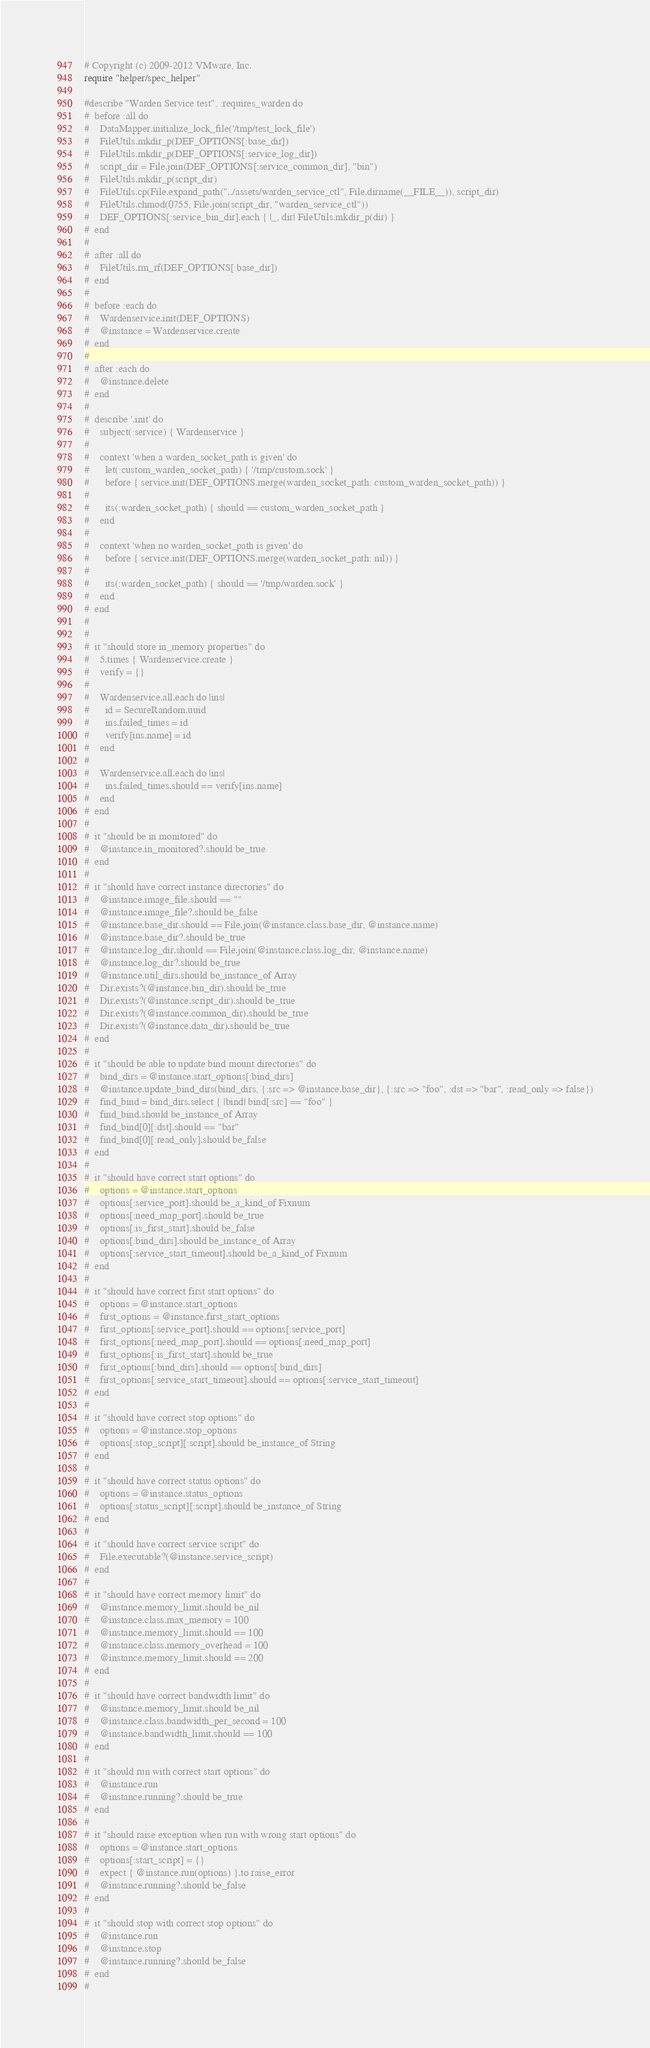Convert code to text. <code><loc_0><loc_0><loc_500><loc_500><_Ruby_># Copyright (c) 2009-2012 VMware, Inc.
require "helper/spec_helper"

#describe "Warden Service test", :requires_warden do
#  before :all do
#    DataMapper.initialize_lock_file('/tmp/test_lock_file')
#    FileUtils.mkdir_p(DEF_OPTIONS[:base_dir])
#    FileUtils.mkdir_p(DEF_OPTIONS[:service_log_dir])
#    script_dir = File.join(DEF_OPTIONS[:service_common_dir], "bin")
#    FileUtils.mkdir_p(script_dir)
#    FileUtils.cp(File.expand_path("../assets/warden_service_ctl", File.dirname(__FILE__)), script_dir)
#    FileUtils.chmod(0755, File.join(script_dir, "warden_service_ctl"))
#    DEF_OPTIONS[:service_bin_dir].each { |_, dir| FileUtils.mkdir_p(dir) }
#  end
#
#  after :all do
#    FileUtils.rm_rf(DEF_OPTIONS[:base_dir])
#  end
#
#  before :each do
#    Wardenservice.init(DEF_OPTIONS)
#    @instance = Wardenservice.create
#  end
#
#  after :each do
#    @instance.delete
#  end
#
#  describe '.init' do
#    subject(:service) { Wardenservice }
#
#    context 'when a warden_socket_path is given' do
#      let(:custom_warden_socket_path) { '/tmp/custom.sock' }
#      before { service.init(DEF_OPTIONS.merge(warden_socket_path: custom_warden_socket_path)) }
#
#      its(:warden_socket_path) { should == custom_warden_socket_path }
#    end
#
#    context 'when no warden_socket_path is given' do
#      before { service.init(DEF_OPTIONS.merge(warden_socket_path: nil)) }
#
#      its(:warden_socket_path) { should == '/tmp/warden.sock' }
#    end
#  end
#
#
#  it "should store in_memory properties" do
#    5.times { Wardenservice.create }
#    verify = {}
#
#    Wardenservice.all.each do |ins|
#      id = SecureRandom.uuid
#      ins.failed_times = id
#      verify[ins.name] = id
#    end
#
#    Wardenservice.all.each do |ins|
#      ins.failed_times.should == verify[ins.name]
#    end
#  end
#
#  it "should be in monitored" do
#    @instance.in_monitored?.should be_true
#  end
#
#  it "should have correct instance directories" do
#    @instance.image_file.should == ""
#    @instance.image_file?.should be_false
#    @instance.base_dir.should == File.join(@instance.class.base_dir, @instance.name)
#    @instance.base_dir?.should be_true
#    @instance.log_dir.should == File.join(@instance.class.log_dir, @instance.name)
#    @instance.log_dir?.should be_true
#    @instance.util_dirs.should be_instance_of Array
#    Dir.exists?(@instance.bin_dir).should be_true
#    Dir.exists?(@instance.script_dir).should be_true
#    Dir.exists?(@instance.common_dir).should be_true
#    Dir.exists?(@instance.data_dir).should be_true
#  end
#
#  it "should be able to update bind mount directories" do
#    bind_dirs = @instance.start_options[:bind_dirs]
#    @instance.update_bind_dirs(bind_dirs, {:src => @instance.base_dir}, {:src => "foo", :dst => "bar", :read_only => false})
#    find_bind = bind_dirs.select { |bind| bind[:src] == "foo" }
#    find_bind.should be_instance_of Array
#    find_bind[0][:dst].should == "bar"
#    find_bind[0][:read_only].should be_false
#  end
#
#  it "should have correct start options" do
#    options = @instance.start_options
#    options[:service_port].should be_a_kind_of Fixnum
#    options[:need_map_port].should be_true
#    options[:is_first_start].should be_false
#    options[:bind_dirs].should be_instance_of Array
#    options[:service_start_timeout].should be_a_kind_of Fixnum
#  end
#
#  it "should have correct first start options" do
#    options = @instance.start_options
#    first_options = @instance.first_start_options
#    first_options[:service_port].should == options[:service_port]
#    first_options[:need_map_port].should == options[:need_map_port]
#    first_options[:is_first_start].should be_true
#    first_options[:bind_dirs].should == options[:bind_dirs]
#    first_options[:service_start_timeout].should == options[:service_start_timeout]
#  end
#
#  it "should have correct stop options" do
#    options = @instance.stop_options
#    options[:stop_script][:script].should be_instance_of String
#  end
#
#  it "should have correct status options" do
#    options = @instance.status_options
#    options[:status_script][:script].should be_instance_of String
#  end
#
#  it "should have correct service script" do
#    File.executable?(@instance.service_script)
#  end
#
#  it "should have correct memory limit" do
#    @instance.memory_limit.should be_nil
#    @instance.class.max_memory = 100
#    @instance.memory_limit.should == 100
#    @instance.class.memory_overhead = 100
#    @instance.memory_limit.should == 200
#  end
#
#  it "should have correct bandwidth limit" do
#    @instance.memory_limit.should be_nil
#    @instance.class.bandwidth_per_second = 100
#    @instance.bandwidth_limit.should == 100
#  end
#
#  it "should run with correct start options" do
#    @instance.run
#    @instance.running?.should be_true
#  end
#
#  it "should raise exception when run with wrong start options" do
#    options = @instance.start_options
#    options[:start_script] = {}
#    expect { @instance.run(options) }.to raise_error
#    @instance.running?.should be_false
#  end
#
#  it "should stop with correct stop options" do
#    @instance.run
#    @instance.stop
#    @instance.running?.should be_false
#  end
#</code> 